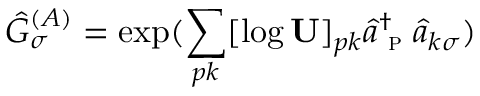Convert formula to latex. <formula><loc_0><loc_0><loc_500><loc_500>\hat { G } _ { \sigma } ^ { ( A ) } = \exp ( \sum _ { p k } [ \log U ] _ { p k } \hat { a } _ { p } ^ { \dagger } \hat { a } _ { k \sigma } )</formula> 